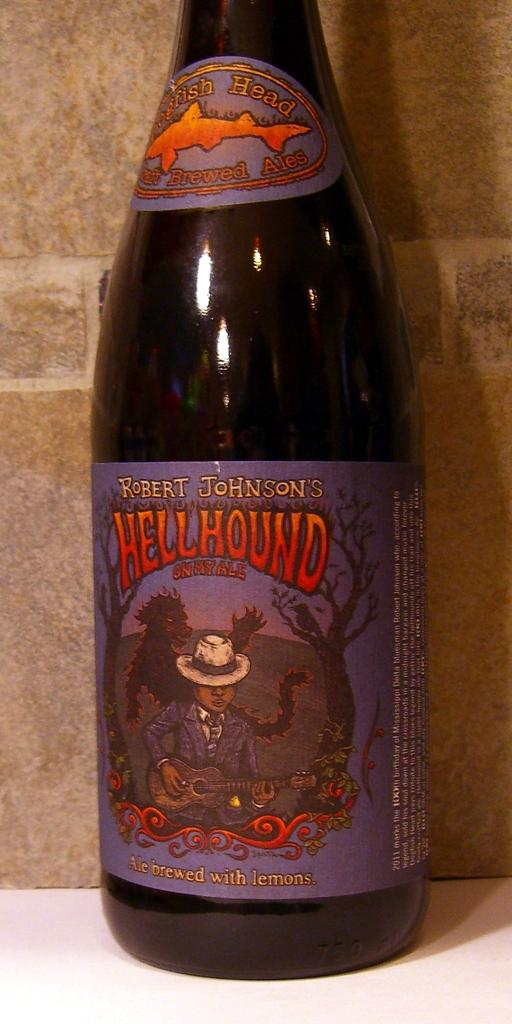<image>
Share a concise interpretation of the image provided. A bottle of Hellhound ale from Dogfish Head brewery. 